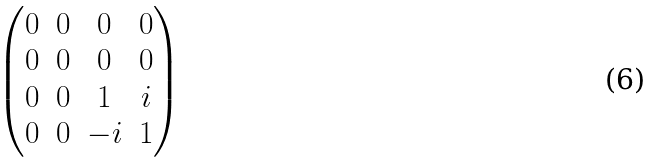Convert formula to latex. <formula><loc_0><loc_0><loc_500><loc_500>\begin{pmatrix} 0 & 0 & 0 & 0 \\ 0 & 0 & 0 & 0 \\ 0 & 0 & 1 & i \\ 0 & 0 & - i & 1 \end{pmatrix}</formula> 